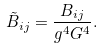Convert formula to latex. <formula><loc_0><loc_0><loc_500><loc_500>\tilde { B } _ { i j } = \frac { B _ { i j } } { g ^ { 4 } G ^ { 4 } } .</formula> 